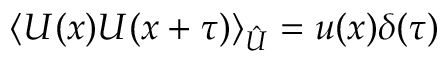Convert formula to latex. <formula><loc_0><loc_0><loc_500><loc_500>\langle U ( x ) U ( x + \tau ) \rangle _ { \hat { U } } = u ( x ) \delta ( \tau )</formula> 